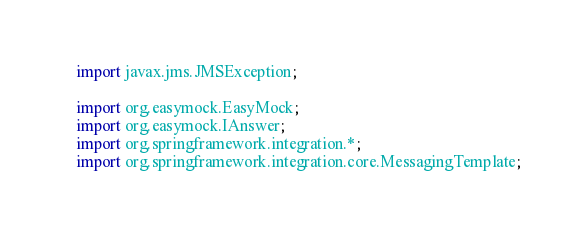<code> <loc_0><loc_0><loc_500><loc_500><_Java_>import javax.jms.JMSException;

import org.easymock.EasyMock;
import org.easymock.IAnswer;
import org.springframework.integration.*;
import org.springframework.integration.core.MessagingTemplate;</code> 